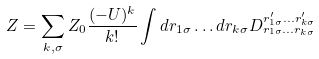Convert formula to latex. <formula><loc_0><loc_0><loc_500><loc_500>Z = \sum _ { k , \sigma } Z _ { 0 } \frac { ( - U ) ^ { k } } { k ! } \int d r _ { 1 \sigma } \dots d r _ { k \sigma } D ^ { r ^ { \prime } _ { 1 \sigma } \dots r ^ { \prime } _ { k \sigma } } _ { r _ { 1 \sigma } \dots r _ { k \sigma } }</formula> 